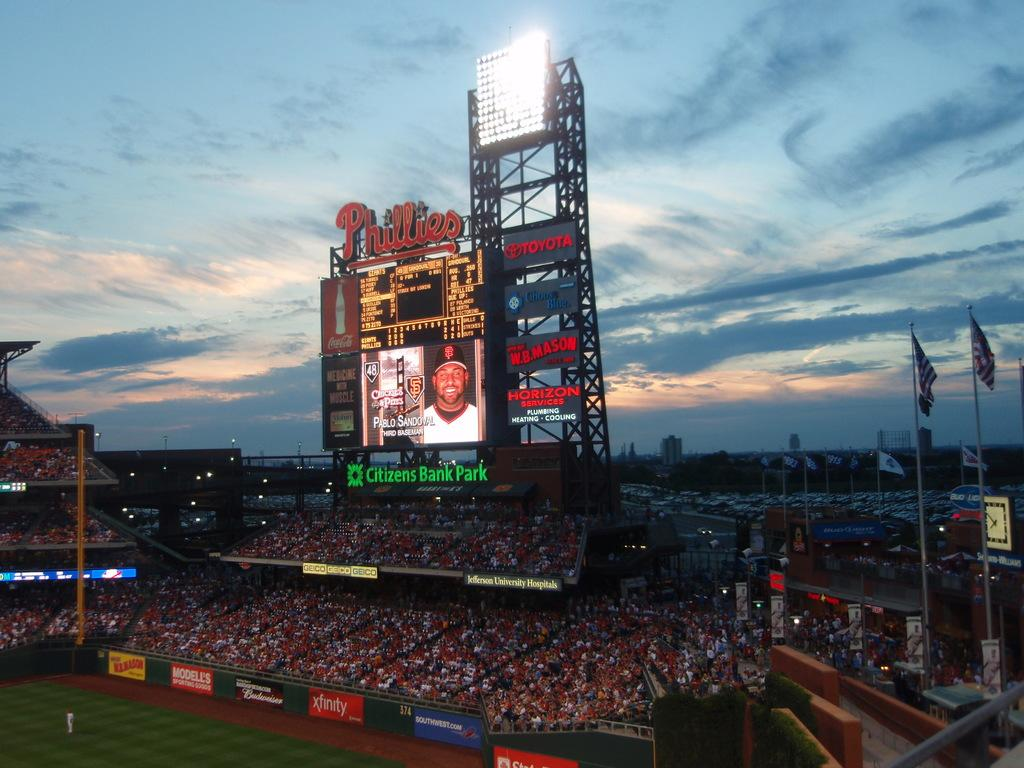<image>
Create a compact narrative representing the image presented. A beautiful evening at the Phillies baseball game. 